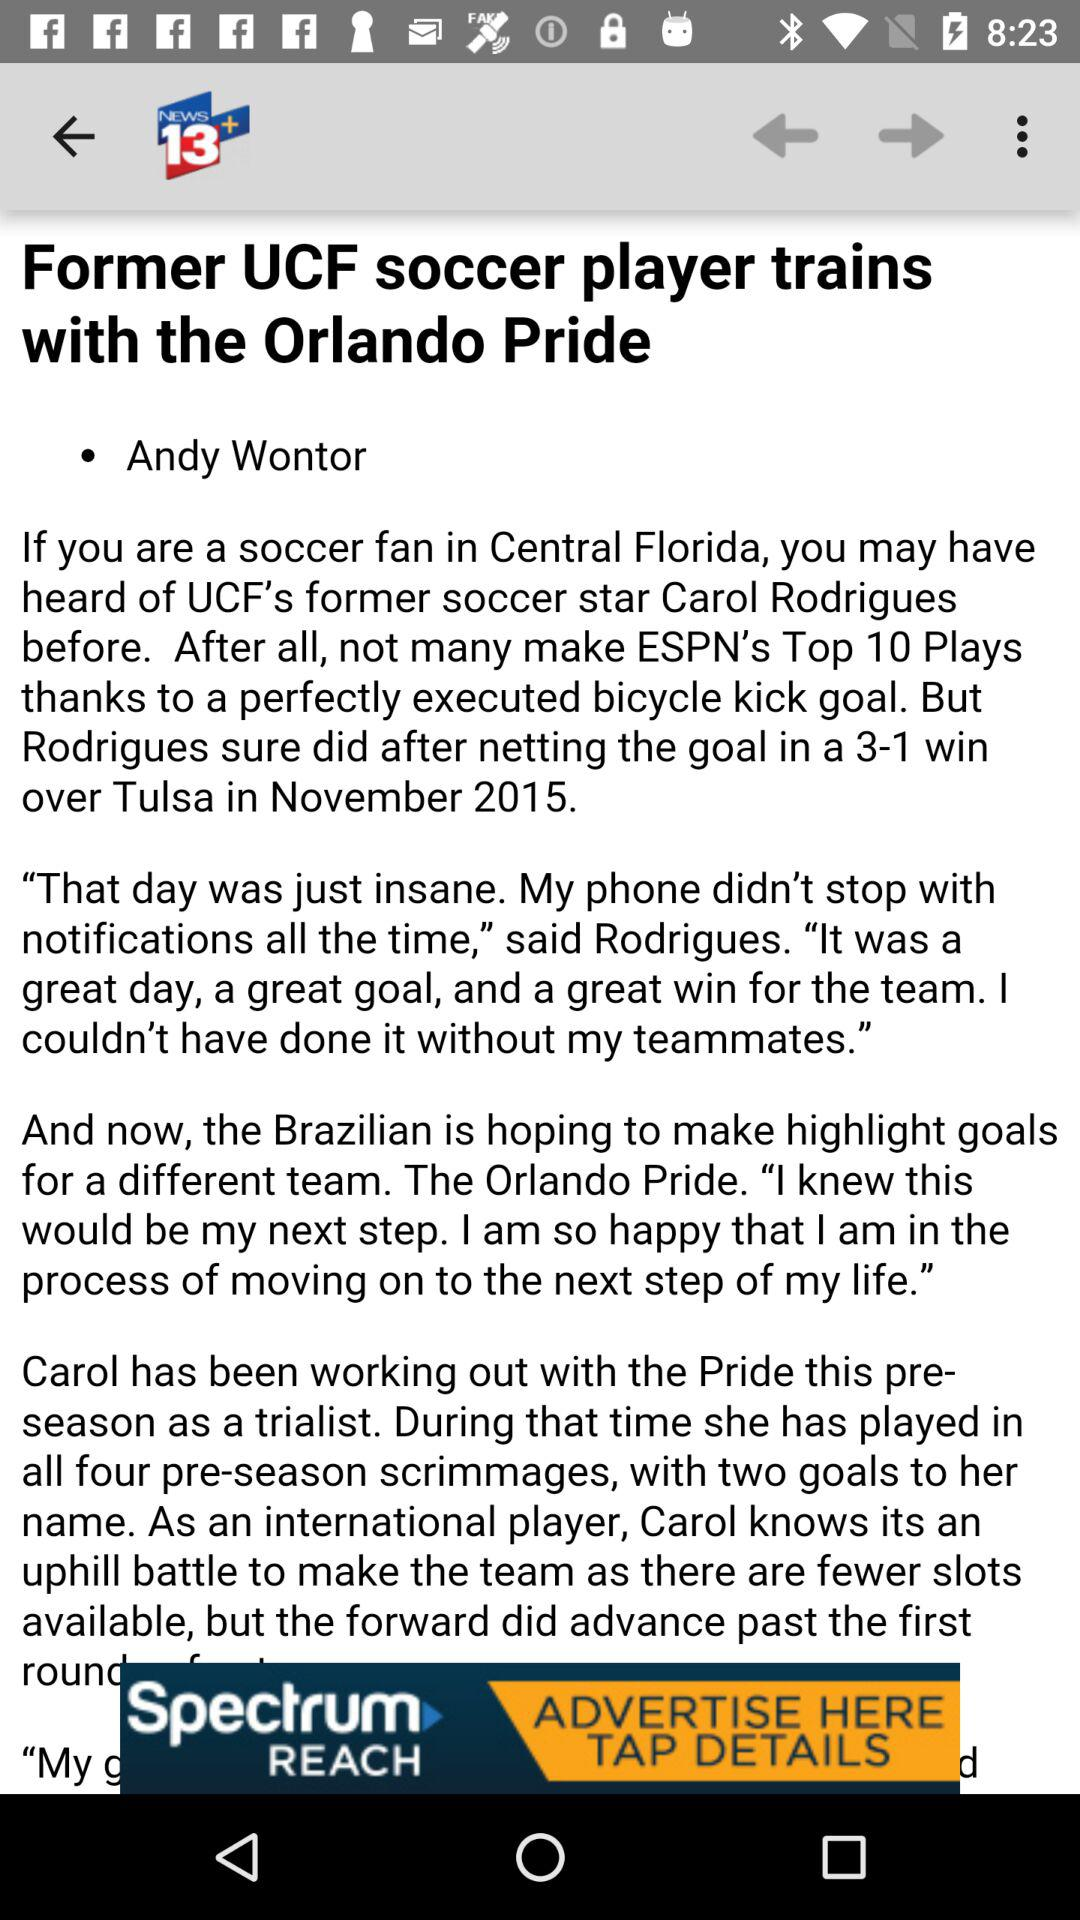How many goals did Carol score in the 3-1 win over Tulsa?
Answer the question using a single word or phrase. 1 